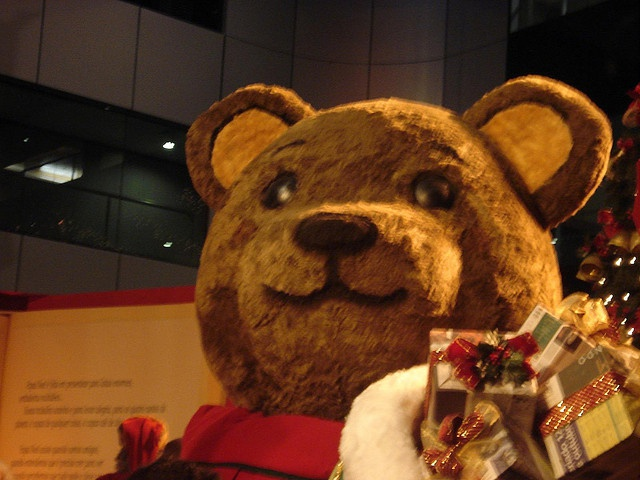Describe the objects in this image and their specific colors. I can see a teddy bear in black, maroon, and brown tones in this image. 